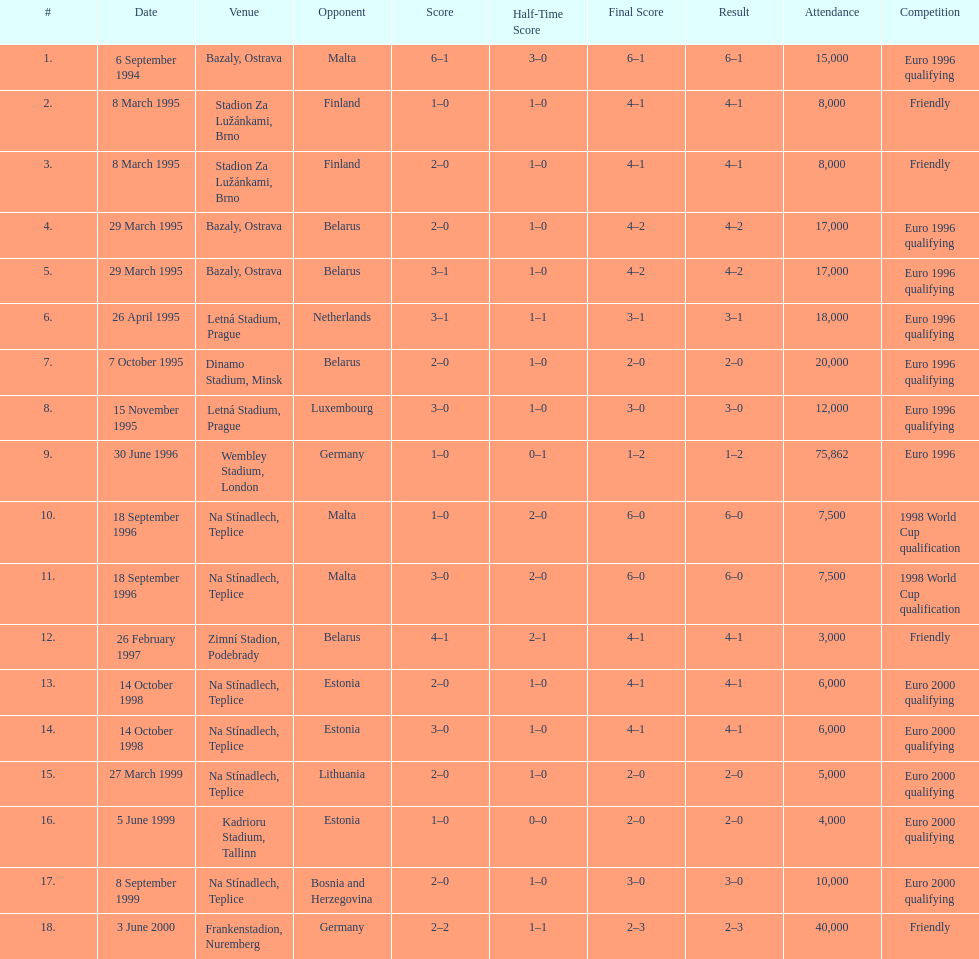Which team did czech republic score the most goals against? Malta. 